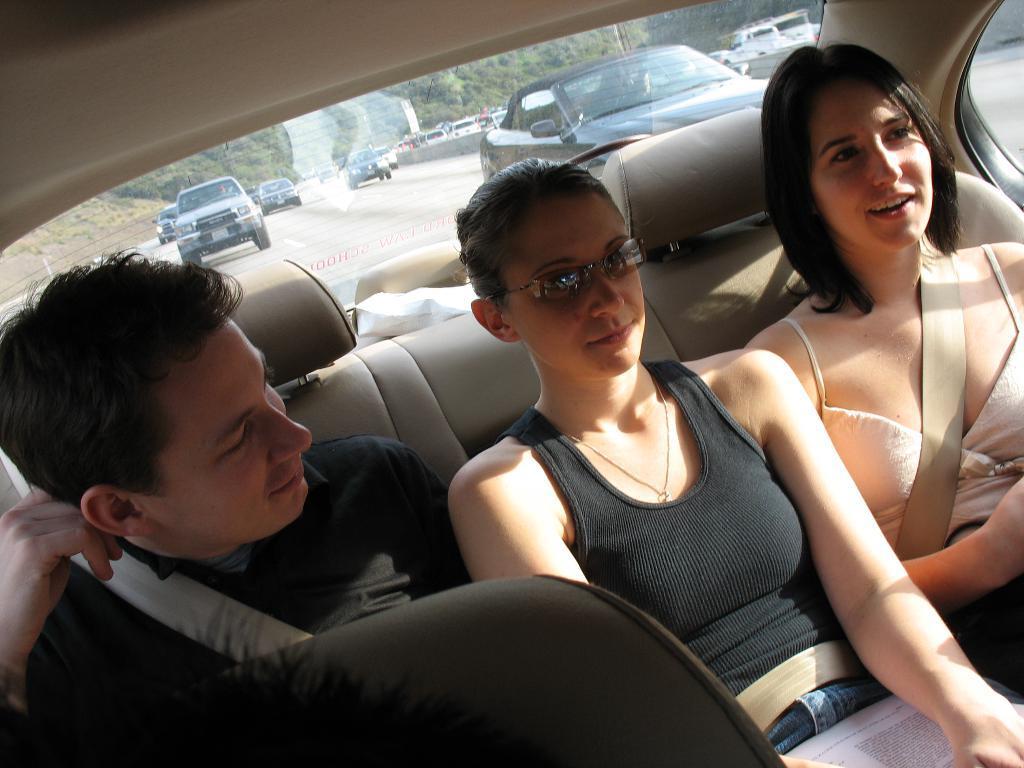How would you summarize this image in a sentence or two? In this image I can see some some in the car. In the background, I can see some vehicles on the road. 